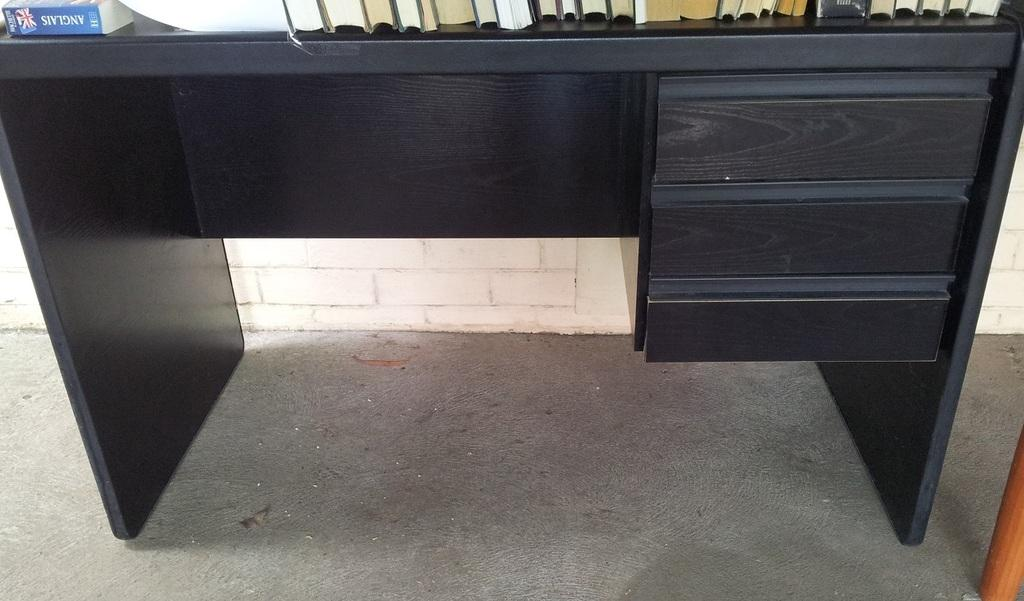What is the main object in the foreground of the image? There is a black desk in the foreground of the image. What is placed on the desk? Books are placed on the desk. What type of quartz can be seen on the desk in the image? There is no quartz present on the desk in the image. How many chickens are visible on the desk in the image? There are no chickens present on the desk in the image. 